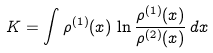<formula> <loc_0><loc_0><loc_500><loc_500>K = \int \rho ^ { ( 1 ) } ( x ) \, \ln { \frac { \rho ^ { ( 1 ) } ( x ) } { \rho ^ { ( 2 ) } ( x ) } } \, d x</formula> 